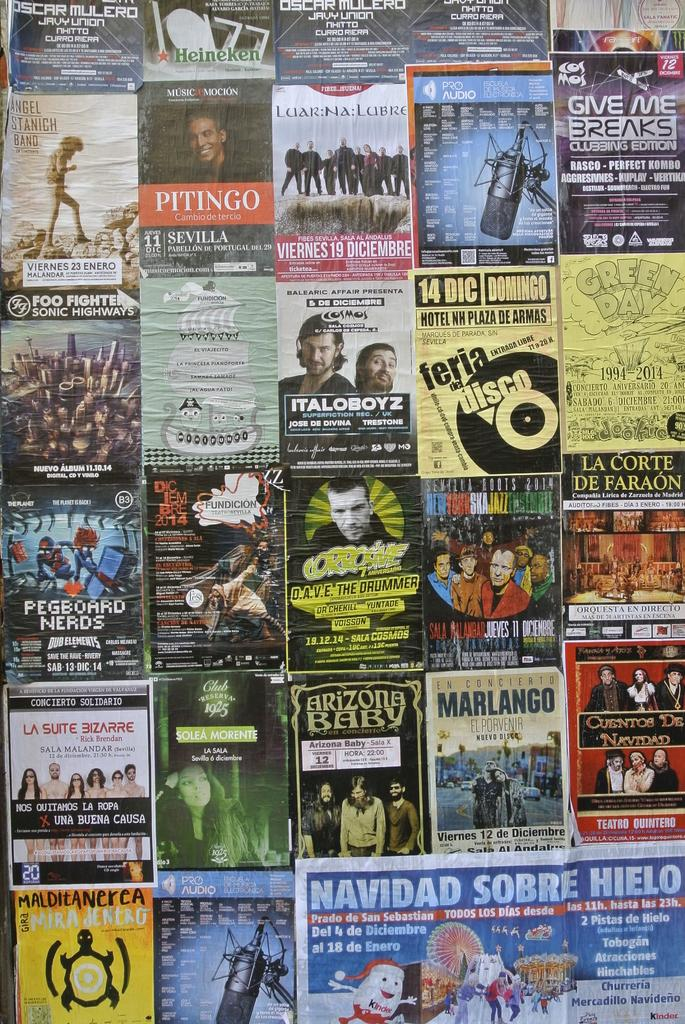What is the main subject of the posters in the image? The posters contain pictures of people. What else can be found on the posters besides the images of people? The posters contain text. What type of wrist support is shown on the posters? There is no wrist support depicted on the posters; they contain pictures of people and text. 